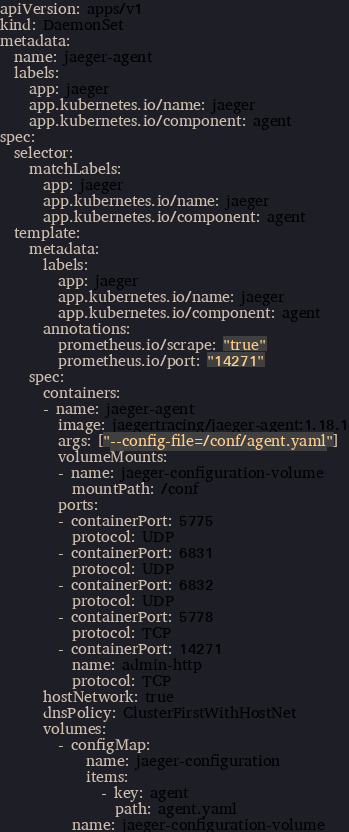<code> <loc_0><loc_0><loc_500><loc_500><_YAML_>apiVersion: apps/v1
kind: DaemonSet
metadata:
  name: jaeger-agent
  labels:
    app: jaeger
    app.kubernetes.io/name: jaeger
    app.kubernetes.io/component: agent
spec:
  selector:
    matchLabels:
      app: jaeger
      app.kubernetes.io/name: jaeger
      app.kubernetes.io/component: agent
  template:
    metadata:
      labels:
        app: jaeger
        app.kubernetes.io/name: jaeger
        app.kubernetes.io/component: agent
      annotations:
        prometheus.io/scrape: "true"
        prometheus.io/port: "14271"
    spec:
      containers:
      - name: jaeger-agent
        image: jaegertracing/jaeger-agent:1.18.1
        args: ["--config-file=/conf/agent.yaml"]
        volumeMounts:
        - name: jaeger-configuration-volume
          mountPath: /conf
        ports:
        - containerPort: 5775
          protocol: UDP
        - containerPort: 6831
          protocol: UDP
        - containerPort: 6832
          protocol: UDP
        - containerPort: 5778
          protocol: TCP
        - containerPort: 14271
          name: admin-http
          protocol: TCP
      hostNetwork: true
      dnsPolicy: ClusterFirstWithHostNet
      volumes:
        - configMap:
            name: jaeger-configuration
            items:
              - key: agent
                path: agent.yaml
          name: jaeger-configuration-volume</code> 